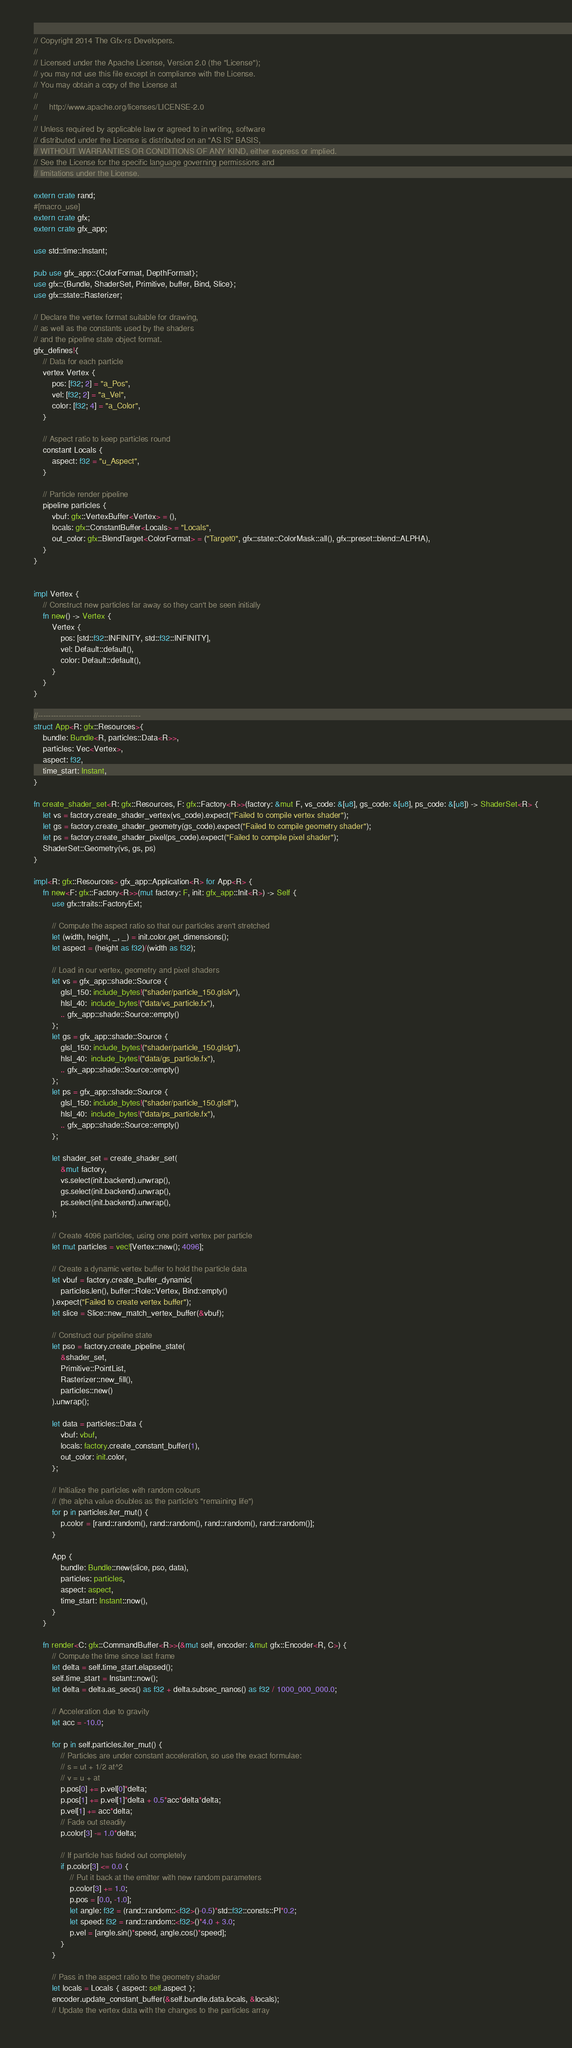<code> <loc_0><loc_0><loc_500><loc_500><_Rust_>// Copyright 2014 The Gfx-rs Developers.
//
// Licensed under the Apache License, Version 2.0 (the "License");
// you may not use this file except in compliance with the License.
// You may obtain a copy of the License at
//
//     http://www.apache.org/licenses/LICENSE-2.0
//
// Unless required by applicable law or agreed to in writing, software
// distributed under the License is distributed on an "AS IS" BASIS,
// WITHOUT WARRANTIES OR CONDITIONS OF ANY KIND, either express or implied.
// See the License for the specific language governing permissions and
// limitations under the License.

extern crate rand;
#[macro_use]
extern crate gfx;
extern crate gfx_app;

use std::time::Instant;

pub use gfx_app::{ColorFormat, DepthFormat};
use gfx::{Bundle, ShaderSet, Primitive, buffer, Bind, Slice};
use gfx::state::Rasterizer;

// Declare the vertex format suitable for drawing,
// as well as the constants used by the shaders
// and the pipeline state object format.
gfx_defines!{
    // Data for each particle
    vertex Vertex {
        pos: [f32; 2] = "a_Pos",
        vel: [f32; 2] = "a_Vel",
        color: [f32; 4] = "a_Color",
    }

    // Aspect ratio to keep particles round
    constant Locals {
        aspect: f32 = "u_Aspect",
    }

    // Particle render pipeline
    pipeline particles {
        vbuf: gfx::VertexBuffer<Vertex> = (),
        locals: gfx::ConstantBuffer<Locals> = "Locals",
        out_color: gfx::BlendTarget<ColorFormat> = ("Target0", gfx::state::ColorMask::all(), gfx::preset::blend::ALPHA),
    }
}


impl Vertex {
    // Construct new particles far away so they can't be seen initially
    fn new() -> Vertex {
        Vertex {
            pos: [std::f32::INFINITY, std::f32::INFINITY],
            vel: Default::default(),
            color: Default::default(),
        }
    }
}

//----------------------------------------
struct App<R: gfx::Resources>{
    bundle: Bundle<R, particles::Data<R>>,
    particles: Vec<Vertex>,
    aspect: f32,
    time_start: Instant,
}

fn create_shader_set<R: gfx::Resources, F: gfx::Factory<R>>(factory: &mut F, vs_code: &[u8], gs_code: &[u8], ps_code: &[u8]) -> ShaderSet<R> {
    let vs = factory.create_shader_vertex(vs_code).expect("Failed to compile vertex shader");
    let gs = factory.create_shader_geometry(gs_code).expect("Failed to compile geometry shader");
    let ps = factory.create_shader_pixel(ps_code).expect("Failed to compile pixel shader");
    ShaderSet::Geometry(vs, gs, ps)
}

impl<R: gfx::Resources> gfx_app::Application<R> for App<R> {
    fn new<F: gfx::Factory<R>>(mut factory: F, init: gfx_app::Init<R>) -> Self {
        use gfx::traits::FactoryExt;

        // Compute the aspect ratio so that our particles aren't stretched
        let (width, height, _, _) = init.color.get_dimensions();
        let aspect = (height as f32)/(width as f32);

        // Load in our vertex, geometry and pixel shaders
        let vs = gfx_app::shade::Source {
            glsl_150: include_bytes!("shader/particle_150.glslv"),
            hlsl_40:  include_bytes!("data/vs_particle.fx"),
            .. gfx_app::shade::Source::empty()
        };
        let gs = gfx_app::shade::Source {
            glsl_150: include_bytes!("shader/particle_150.glslg"),
            hlsl_40:  include_bytes!("data/gs_particle.fx"),
            .. gfx_app::shade::Source::empty()
        };
        let ps = gfx_app::shade::Source {
            glsl_150: include_bytes!("shader/particle_150.glslf"),
            hlsl_40:  include_bytes!("data/ps_particle.fx"),
            .. gfx_app::shade::Source::empty()
        };

        let shader_set = create_shader_set(
            &mut factory,
            vs.select(init.backend).unwrap(),
            gs.select(init.backend).unwrap(),
            ps.select(init.backend).unwrap(),
        );

        // Create 4096 particles, using one point vertex per particle
        let mut particles = vec![Vertex::new(); 4096];

        // Create a dynamic vertex buffer to hold the particle data
        let vbuf = factory.create_buffer_dynamic(
            particles.len(), buffer::Role::Vertex, Bind::empty()
        ).expect("Failed to create vertex buffer");
        let slice = Slice::new_match_vertex_buffer(&vbuf);

        // Construct our pipeline state
        let pso = factory.create_pipeline_state(
            &shader_set,
            Primitive::PointList,
            Rasterizer::new_fill(),
            particles::new()
        ).unwrap();

        let data = particles::Data {
            vbuf: vbuf,
            locals: factory.create_constant_buffer(1),
            out_color: init.color,
        };

        // Initialize the particles with random colours
        // (the alpha value doubles as the particle's "remaining life")
        for p in particles.iter_mut() {
            p.color = [rand::random(), rand::random(), rand::random(), rand::random()];
        }

        App {
            bundle: Bundle::new(slice, pso, data),
            particles: particles,
            aspect: aspect,
            time_start: Instant::now(),
        }
    }

    fn render<C: gfx::CommandBuffer<R>>(&mut self, encoder: &mut gfx::Encoder<R, C>) {
        // Compute the time since last frame
        let delta = self.time_start.elapsed();
        self.time_start = Instant::now();
        let delta = delta.as_secs() as f32 + delta.subsec_nanos() as f32 / 1000_000_000.0;

        // Acceleration due to gravity
        let acc = -10.0;

        for p in self.particles.iter_mut() {
            // Particles are under constant acceleration, so use the exact formulae:
            // s = ut + 1/2 at^2
            // v = u + at
            p.pos[0] += p.vel[0]*delta;
            p.pos[1] += p.vel[1]*delta + 0.5*acc*delta*delta;
            p.vel[1] += acc*delta;
            // Fade out steadily
            p.color[3] -= 1.0*delta;

            // If particle has faded out completely
            if p.color[3] <= 0.0 {
                // Put it back at the emitter with new random parameters
                p.color[3] += 1.0;
                p.pos = [0.0, -1.0];
                let angle: f32 = (rand::random::<f32>()-0.5)*std::f32::consts::PI*0.2;
                let speed: f32 = rand::random::<f32>()*4.0 + 3.0;
                p.vel = [angle.sin()*speed, angle.cos()*speed];
            }
        }

        // Pass in the aspect ratio to the geometry shader
        let locals = Locals { aspect: self.aspect };
        encoder.update_constant_buffer(&self.bundle.data.locals, &locals);
        // Update the vertex data with the changes to the particles array</code> 